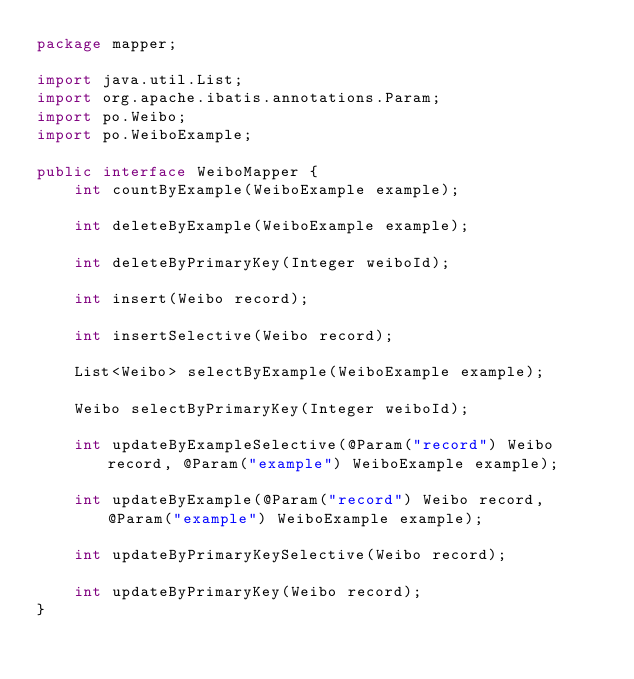Convert code to text. <code><loc_0><loc_0><loc_500><loc_500><_Java_>package mapper;

import java.util.List;
import org.apache.ibatis.annotations.Param;
import po.Weibo;
import po.WeiboExample;

public interface WeiboMapper {
    int countByExample(WeiboExample example);

    int deleteByExample(WeiboExample example);

    int deleteByPrimaryKey(Integer weiboId);

    int insert(Weibo record);

    int insertSelective(Weibo record);

    List<Weibo> selectByExample(WeiboExample example);

    Weibo selectByPrimaryKey(Integer weiboId);

    int updateByExampleSelective(@Param("record") Weibo record, @Param("example") WeiboExample example);

    int updateByExample(@Param("record") Weibo record, @Param("example") WeiboExample example);

    int updateByPrimaryKeySelective(Weibo record);

    int updateByPrimaryKey(Weibo record);
}</code> 